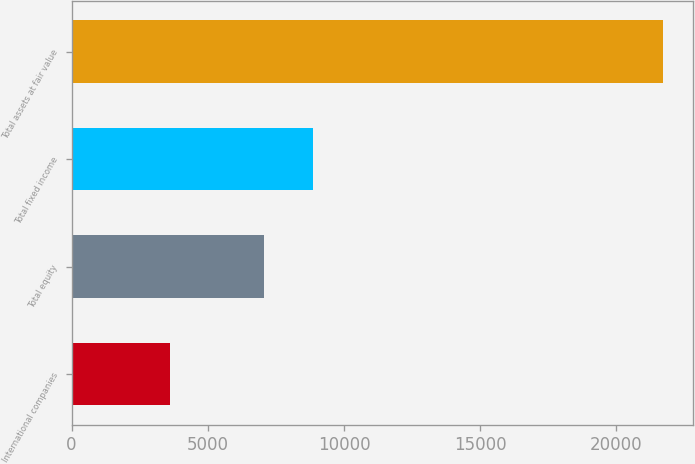Convert chart to OTSL. <chart><loc_0><loc_0><loc_500><loc_500><bar_chart><fcel>International companies<fcel>Total equity<fcel>Total fixed income<fcel>Total assets at fair value<nl><fcel>3613<fcel>7057<fcel>8867<fcel>21713<nl></chart> 